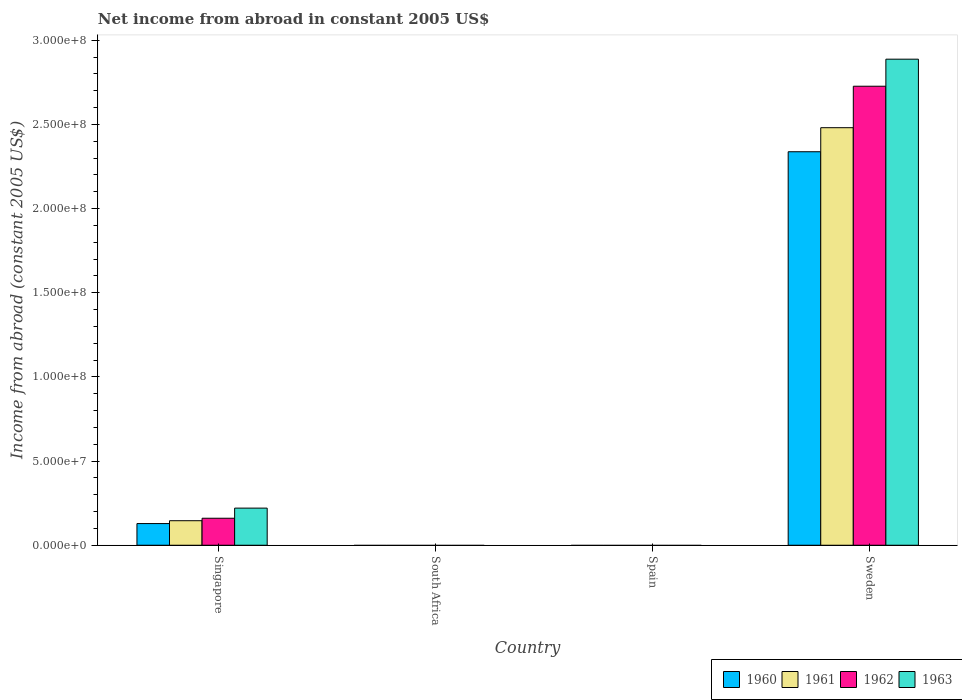How many different coloured bars are there?
Offer a very short reply. 4. Are the number of bars per tick equal to the number of legend labels?
Provide a short and direct response. No. Are the number of bars on each tick of the X-axis equal?
Your answer should be compact. No. How many bars are there on the 3rd tick from the right?
Keep it short and to the point. 0. What is the net income from abroad in 1963 in Singapore?
Ensure brevity in your answer.  2.20e+07. Across all countries, what is the maximum net income from abroad in 1960?
Make the answer very short. 2.34e+08. What is the total net income from abroad in 1962 in the graph?
Make the answer very short. 2.89e+08. What is the difference between the net income from abroad in 1962 in Singapore and the net income from abroad in 1963 in Spain?
Ensure brevity in your answer.  1.60e+07. What is the average net income from abroad in 1960 per country?
Offer a terse response. 6.17e+07. What is the difference between the net income from abroad of/in 1960 and net income from abroad of/in 1962 in Sweden?
Give a very brief answer. -3.89e+07. What is the ratio of the net income from abroad in 1962 in Singapore to that in Sweden?
Offer a terse response. 0.06. What is the difference between the highest and the lowest net income from abroad in 1960?
Make the answer very short. 2.34e+08. Is the sum of the net income from abroad in 1962 in Singapore and Sweden greater than the maximum net income from abroad in 1960 across all countries?
Your answer should be compact. Yes. Is it the case that in every country, the sum of the net income from abroad in 1961 and net income from abroad in 1963 is greater than the sum of net income from abroad in 1960 and net income from abroad in 1962?
Your response must be concise. No. Is it the case that in every country, the sum of the net income from abroad in 1960 and net income from abroad in 1963 is greater than the net income from abroad in 1962?
Make the answer very short. No. How many bars are there?
Provide a short and direct response. 8. What is the difference between two consecutive major ticks on the Y-axis?
Your response must be concise. 5.00e+07. Where does the legend appear in the graph?
Keep it short and to the point. Bottom right. How many legend labels are there?
Your answer should be very brief. 4. What is the title of the graph?
Give a very brief answer. Net income from abroad in constant 2005 US$. What is the label or title of the Y-axis?
Your answer should be very brief. Income from abroad (constant 2005 US$). What is the Income from abroad (constant 2005 US$) of 1960 in Singapore?
Offer a terse response. 1.29e+07. What is the Income from abroad (constant 2005 US$) in 1961 in Singapore?
Your answer should be compact. 1.46e+07. What is the Income from abroad (constant 2005 US$) in 1962 in Singapore?
Ensure brevity in your answer.  1.60e+07. What is the Income from abroad (constant 2005 US$) of 1963 in Singapore?
Provide a short and direct response. 2.20e+07. What is the Income from abroad (constant 2005 US$) in 1960 in South Africa?
Offer a terse response. 0. What is the Income from abroad (constant 2005 US$) of 1963 in South Africa?
Offer a very short reply. 0. What is the Income from abroad (constant 2005 US$) in 1960 in Sweden?
Give a very brief answer. 2.34e+08. What is the Income from abroad (constant 2005 US$) of 1961 in Sweden?
Your answer should be very brief. 2.48e+08. What is the Income from abroad (constant 2005 US$) in 1962 in Sweden?
Give a very brief answer. 2.73e+08. What is the Income from abroad (constant 2005 US$) in 1963 in Sweden?
Keep it short and to the point. 2.89e+08. Across all countries, what is the maximum Income from abroad (constant 2005 US$) of 1960?
Offer a very short reply. 2.34e+08. Across all countries, what is the maximum Income from abroad (constant 2005 US$) in 1961?
Give a very brief answer. 2.48e+08. Across all countries, what is the maximum Income from abroad (constant 2005 US$) of 1962?
Make the answer very short. 2.73e+08. Across all countries, what is the maximum Income from abroad (constant 2005 US$) of 1963?
Your answer should be compact. 2.89e+08. Across all countries, what is the minimum Income from abroad (constant 2005 US$) in 1960?
Give a very brief answer. 0. Across all countries, what is the minimum Income from abroad (constant 2005 US$) of 1961?
Give a very brief answer. 0. Across all countries, what is the minimum Income from abroad (constant 2005 US$) of 1962?
Make the answer very short. 0. What is the total Income from abroad (constant 2005 US$) in 1960 in the graph?
Your response must be concise. 2.47e+08. What is the total Income from abroad (constant 2005 US$) in 1961 in the graph?
Your response must be concise. 2.63e+08. What is the total Income from abroad (constant 2005 US$) in 1962 in the graph?
Your answer should be compact. 2.89e+08. What is the total Income from abroad (constant 2005 US$) in 1963 in the graph?
Your response must be concise. 3.11e+08. What is the difference between the Income from abroad (constant 2005 US$) in 1960 in Singapore and that in Sweden?
Provide a short and direct response. -2.21e+08. What is the difference between the Income from abroad (constant 2005 US$) of 1961 in Singapore and that in Sweden?
Your answer should be very brief. -2.34e+08. What is the difference between the Income from abroad (constant 2005 US$) in 1962 in Singapore and that in Sweden?
Your response must be concise. -2.57e+08. What is the difference between the Income from abroad (constant 2005 US$) in 1963 in Singapore and that in Sweden?
Ensure brevity in your answer.  -2.67e+08. What is the difference between the Income from abroad (constant 2005 US$) in 1960 in Singapore and the Income from abroad (constant 2005 US$) in 1961 in Sweden?
Ensure brevity in your answer.  -2.35e+08. What is the difference between the Income from abroad (constant 2005 US$) in 1960 in Singapore and the Income from abroad (constant 2005 US$) in 1962 in Sweden?
Keep it short and to the point. -2.60e+08. What is the difference between the Income from abroad (constant 2005 US$) in 1960 in Singapore and the Income from abroad (constant 2005 US$) in 1963 in Sweden?
Make the answer very short. -2.76e+08. What is the difference between the Income from abroad (constant 2005 US$) of 1961 in Singapore and the Income from abroad (constant 2005 US$) of 1962 in Sweden?
Offer a terse response. -2.58e+08. What is the difference between the Income from abroad (constant 2005 US$) of 1961 in Singapore and the Income from abroad (constant 2005 US$) of 1963 in Sweden?
Keep it short and to the point. -2.74e+08. What is the difference between the Income from abroad (constant 2005 US$) of 1962 in Singapore and the Income from abroad (constant 2005 US$) of 1963 in Sweden?
Provide a short and direct response. -2.73e+08. What is the average Income from abroad (constant 2005 US$) of 1960 per country?
Provide a succinct answer. 6.17e+07. What is the average Income from abroad (constant 2005 US$) in 1961 per country?
Your answer should be very brief. 6.57e+07. What is the average Income from abroad (constant 2005 US$) of 1962 per country?
Your response must be concise. 7.22e+07. What is the average Income from abroad (constant 2005 US$) of 1963 per country?
Keep it short and to the point. 7.77e+07. What is the difference between the Income from abroad (constant 2005 US$) in 1960 and Income from abroad (constant 2005 US$) in 1961 in Singapore?
Offer a very short reply. -1.70e+06. What is the difference between the Income from abroad (constant 2005 US$) of 1960 and Income from abroad (constant 2005 US$) of 1962 in Singapore?
Provide a succinct answer. -3.17e+06. What is the difference between the Income from abroad (constant 2005 US$) in 1960 and Income from abroad (constant 2005 US$) in 1963 in Singapore?
Provide a succinct answer. -9.18e+06. What is the difference between the Income from abroad (constant 2005 US$) of 1961 and Income from abroad (constant 2005 US$) of 1962 in Singapore?
Give a very brief answer. -1.47e+06. What is the difference between the Income from abroad (constant 2005 US$) of 1961 and Income from abroad (constant 2005 US$) of 1963 in Singapore?
Your answer should be very brief. -7.48e+06. What is the difference between the Income from abroad (constant 2005 US$) of 1962 and Income from abroad (constant 2005 US$) of 1963 in Singapore?
Offer a very short reply. -6.01e+06. What is the difference between the Income from abroad (constant 2005 US$) of 1960 and Income from abroad (constant 2005 US$) of 1961 in Sweden?
Provide a succinct answer. -1.43e+07. What is the difference between the Income from abroad (constant 2005 US$) of 1960 and Income from abroad (constant 2005 US$) of 1962 in Sweden?
Your response must be concise. -3.89e+07. What is the difference between the Income from abroad (constant 2005 US$) in 1960 and Income from abroad (constant 2005 US$) in 1963 in Sweden?
Ensure brevity in your answer.  -5.50e+07. What is the difference between the Income from abroad (constant 2005 US$) in 1961 and Income from abroad (constant 2005 US$) in 1962 in Sweden?
Your answer should be very brief. -2.46e+07. What is the difference between the Income from abroad (constant 2005 US$) in 1961 and Income from abroad (constant 2005 US$) in 1963 in Sweden?
Your response must be concise. -4.07e+07. What is the difference between the Income from abroad (constant 2005 US$) in 1962 and Income from abroad (constant 2005 US$) in 1963 in Sweden?
Your answer should be very brief. -1.61e+07. What is the ratio of the Income from abroad (constant 2005 US$) in 1960 in Singapore to that in Sweden?
Your answer should be compact. 0.06. What is the ratio of the Income from abroad (constant 2005 US$) in 1961 in Singapore to that in Sweden?
Provide a succinct answer. 0.06. What is the ratio of the Income from abroad (constant 2005 US$) in 1962 in Singapore to that in Sweden?
Offer a very short reply. 0.06. What is the ratio of the Income from abroad (constant 2005 US$) in 1963 in Singapore to that in Sweden?
Keep it short and to the point. 0.08. What is the difference between the highest and the lowest Income from abroad (constant 2005 US$) in 1960?
Your response must be concise. 2.34e+08. What is the difference between the highest and the lowest Income from abroad (constant 2005 US$) in 1961?
Your answer should be compact. 2.48e+08. What is the difference between the highest and the lowest Income from abroad (constant 2005 US$) of 1962?
Your answer should be compact. 2.73e+08. What is the difference between the highest and the lowest Income from abroad (constant 2005 US$) of 1963?
Make the answer very short. 2.89e+08. 